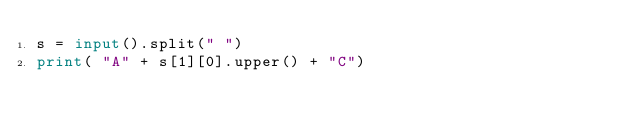<code> <loc_0><loc_0><loc_500><loc_500><_Python_>s = input().split(" ")
print( "A" + s[1][0].upper() + "C")
</code> 